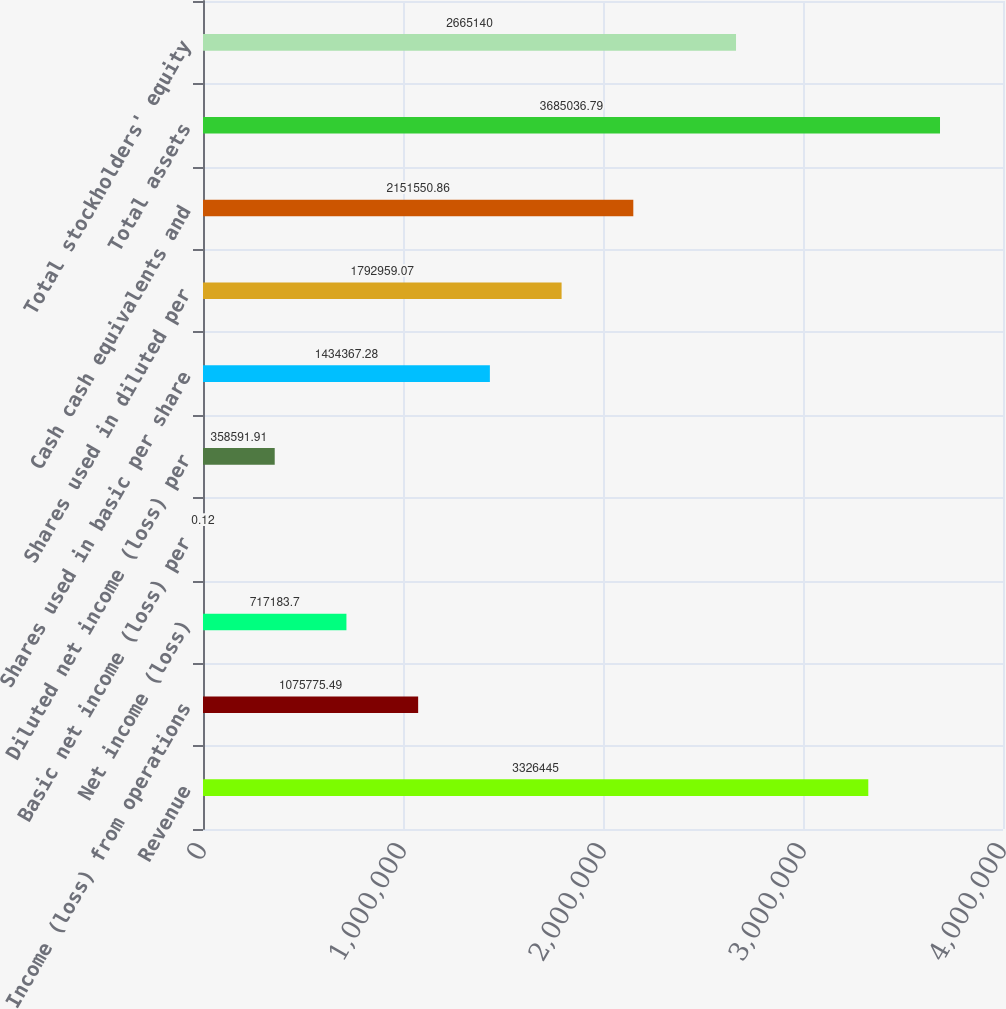<chart> <loc_0><loc_0><loc_500><loc_500><bar_chart><fcel>Revenue<fcel>Income (loss) from operations<fcel>Net income (loss)<fcel>Basic net income (loss) per<fcel>Diluted net income (loss) per<fcel>Shares used in basic per share<fcel>Shares used in diluted per<fcel>Cash cash equivalents and<fcel>Total assets<fcel>Total stockholders' equity<nl><fcel>3.32644e+06<fcel>1.07578e+06<fcel>717184<fcel>0.12<fcel>358592<fcel>1.43437e+06<fcel>1.79296e+06<fcel>2.15155e+06<fcel>3.68504e+06<fcel>2.66514e+06<nl></chart> 